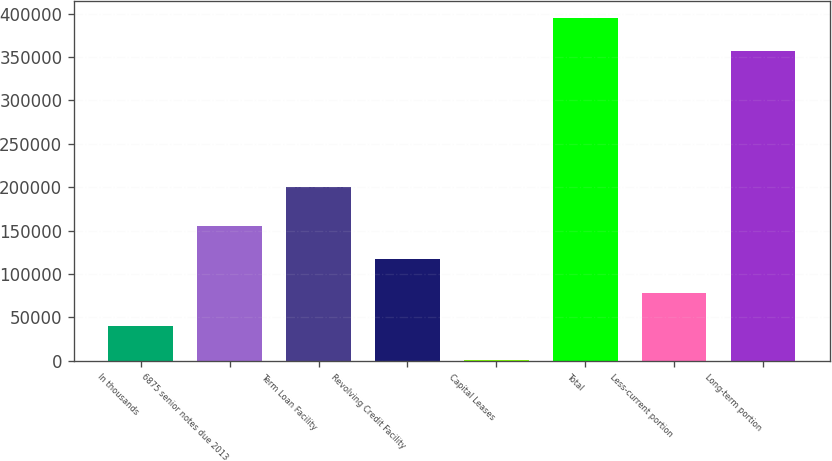Convert chart. <chart><loc_0><loc_0><loc_500><loc_500><bar_chart><fcel>In thousands<fcel>6875 senior notes due 2013<fcel>Term Loan Facility<fcel>Revolving Credit Facility<fcel>Capital Leases<fcel>Total<fcel>Less-current portion<fcel>Long-term portion<nl><fcel>39680<fcel>155480<fcel>200000<fcel>116880<fcel>1080<fcel>395299<fcel>78280<fcel>356699<nl></chart> 